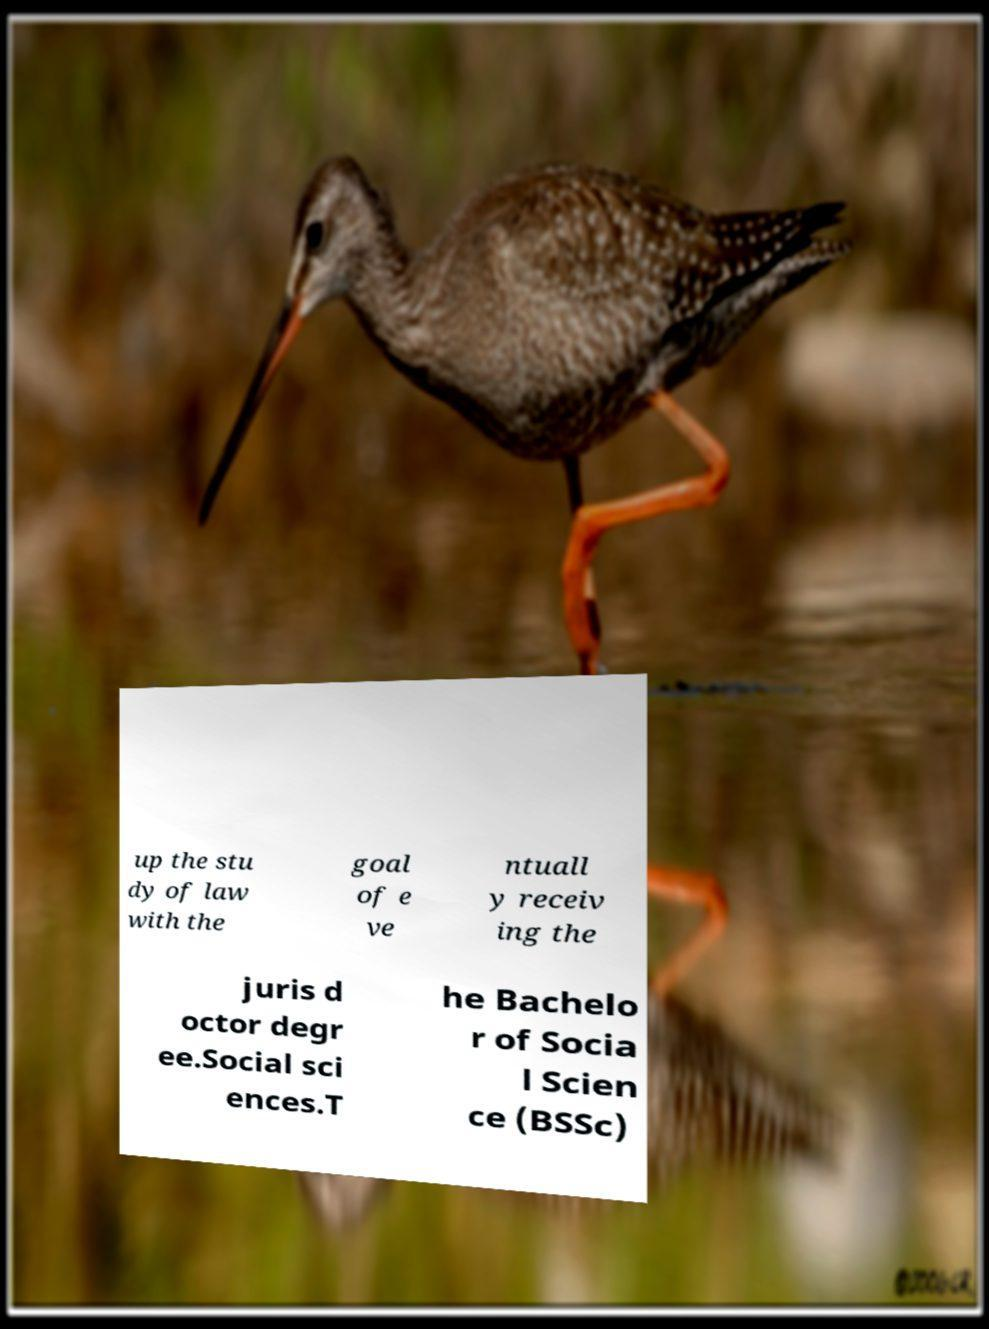Can you accurately transcribe the text from the provided image for me? up the stu dy of law with the goal of e ve ntuall y receiv ing the juris d octor degr ee.Social sci ences.T he Bachelo r of Socia l Scien ce (BSSc) 